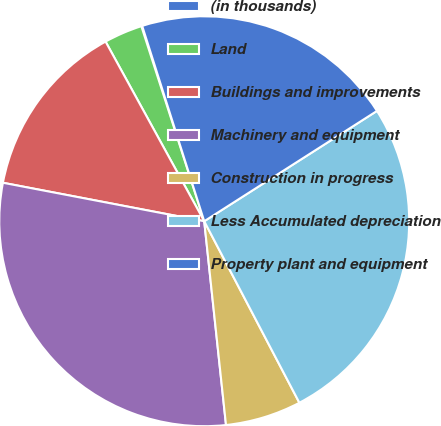<chart> <loc_0><loc_0><loc_500><loc_500><pie_chart><fcel>(in thousands)<fcel>Land<fcel>Buildings and improvements<fcel>Machinery and equipment<fcel>Construction in progress<fcel>Less Accumulated depreciation<fcel>Property plant and equipment<nl><fcel>0.07%<fcel>3.03%<fcel>14.0%<fcel>29.7%<fcel>5.99%<fcel>26.36%<fcel>20.85%<nl></chart> 